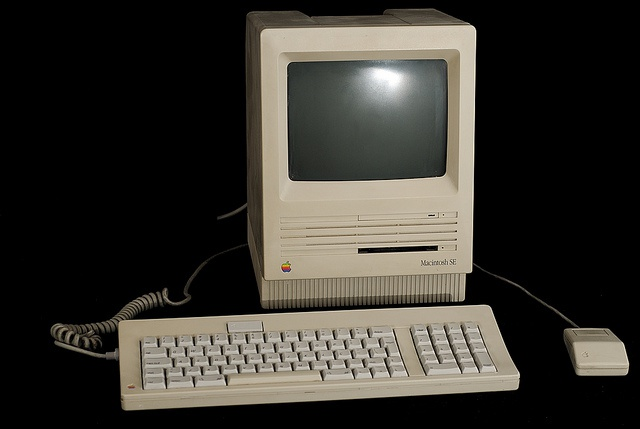Describe the objects in this image and their specific colors. I can see tv in black, tan, and gray tones, keyboard in black, darkgray, and gray tones, and mouse in black, darkgray, and gray tones in this image. 